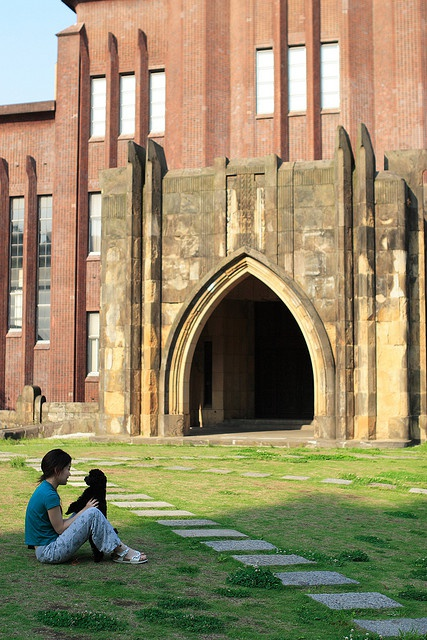Describe the objects in this image and their specific colors. I can see people in lightblue, black, blue, and gray tones and dog in lightblue, black, olive, darkgreen, and gray tones in this image. 